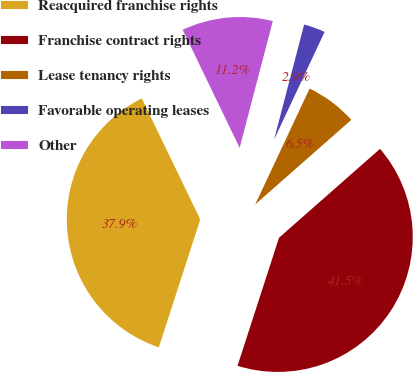Convert chart to OTSL. <chart><loc_0><loc_0><loc_500><loc_500><pie_chart><fcel>Reacquired franchise rights<fcel>Franchise contract rights<fcel>Lease tenancy rights<fcel>Favorable operating leases<fcel>Other<nl><fcel>37.85%<fcel>41.47%<fcel>6.53%<fcel>2.91%<fcel>11.23%<nl></chart> 